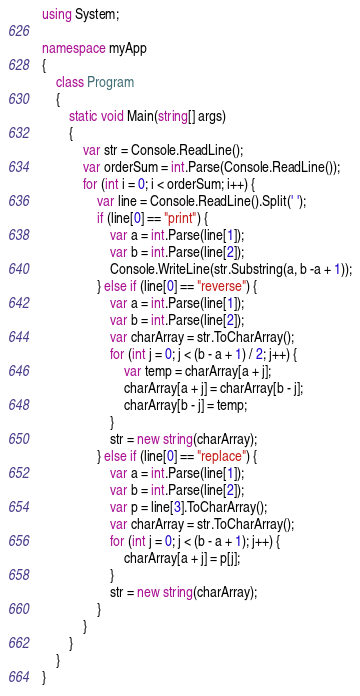<code> <loc_0><loc_0><loc_500><loc_500><_C#_>using System;

namespace myApp
{
    class Program
    {
        static void Main(string[] args)
        {
            var str = Console.ReadLine();
            var orderSum = int.Parse(Console.ReadLine());
            for (int i = 0; i < orderSum; i++) {
                var line = Console.ReadLine().Split(' ');
                if (line[0] == "print") {
                    var a = int.Parse(line[1]);
                    var b = int.Parse(line[2]);
                    Console.WriteLine(str.Substring(a, b -a + 1));
                } else if (line[0] == "reverse") {
                    var a = int.Parse(line[1]);
                    var b = int.Parse(line[2]);
                    var charArray = str.ToCharArray();
                    for (int j = 0; j < (b - a + 1) / 2; j++) {
                        var temp = charArray[a + j];
                        charArray[a + j] = charArray[b - j];
                        charArray[b - j] = temp;
                    }
                    str = new string(charArray);
                } else if (line[0] == "replace") {
                    var a = int.Parse(line[1]);
                    var b = int.Parse(line[2]);
                    var p = line[3].ToCharArray();
                    var charArray = str.ToCharArray();
                    for (int j = 0; j < (b - a + 1); j++) {
                        charArray[a + j] = p[j];
                    }
                    str = new string(charArray);
                }
            }
        }
    }
}

</code> 